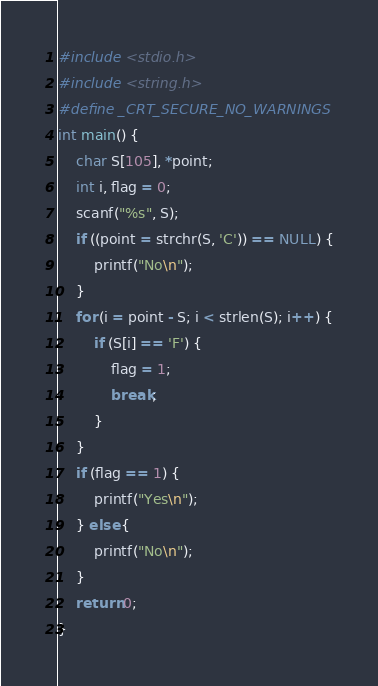<code> <loc_0><loc_0><loc_500><loc_500><_C_>#include <stdio.h>
#include <string.h>
#define _CRT_SECURE_NO_WARNINGS
int main() {
	char S[105], *point;
	int i, flag = 0;
	scanf("%s", S);
	if ((point = strchr(S, 'C')) == NULL) {
		printf("No\n");
	}
	for (i = point - S; i < strlen(S); i++) {
		if (S[i] == 'F') {
			flag = 1;
			break;
		}
	}
	if (flag == 1) {
		printf("Yes\n");
	} else {
		printf("No\n");
	}
	return 0;
}</code> 